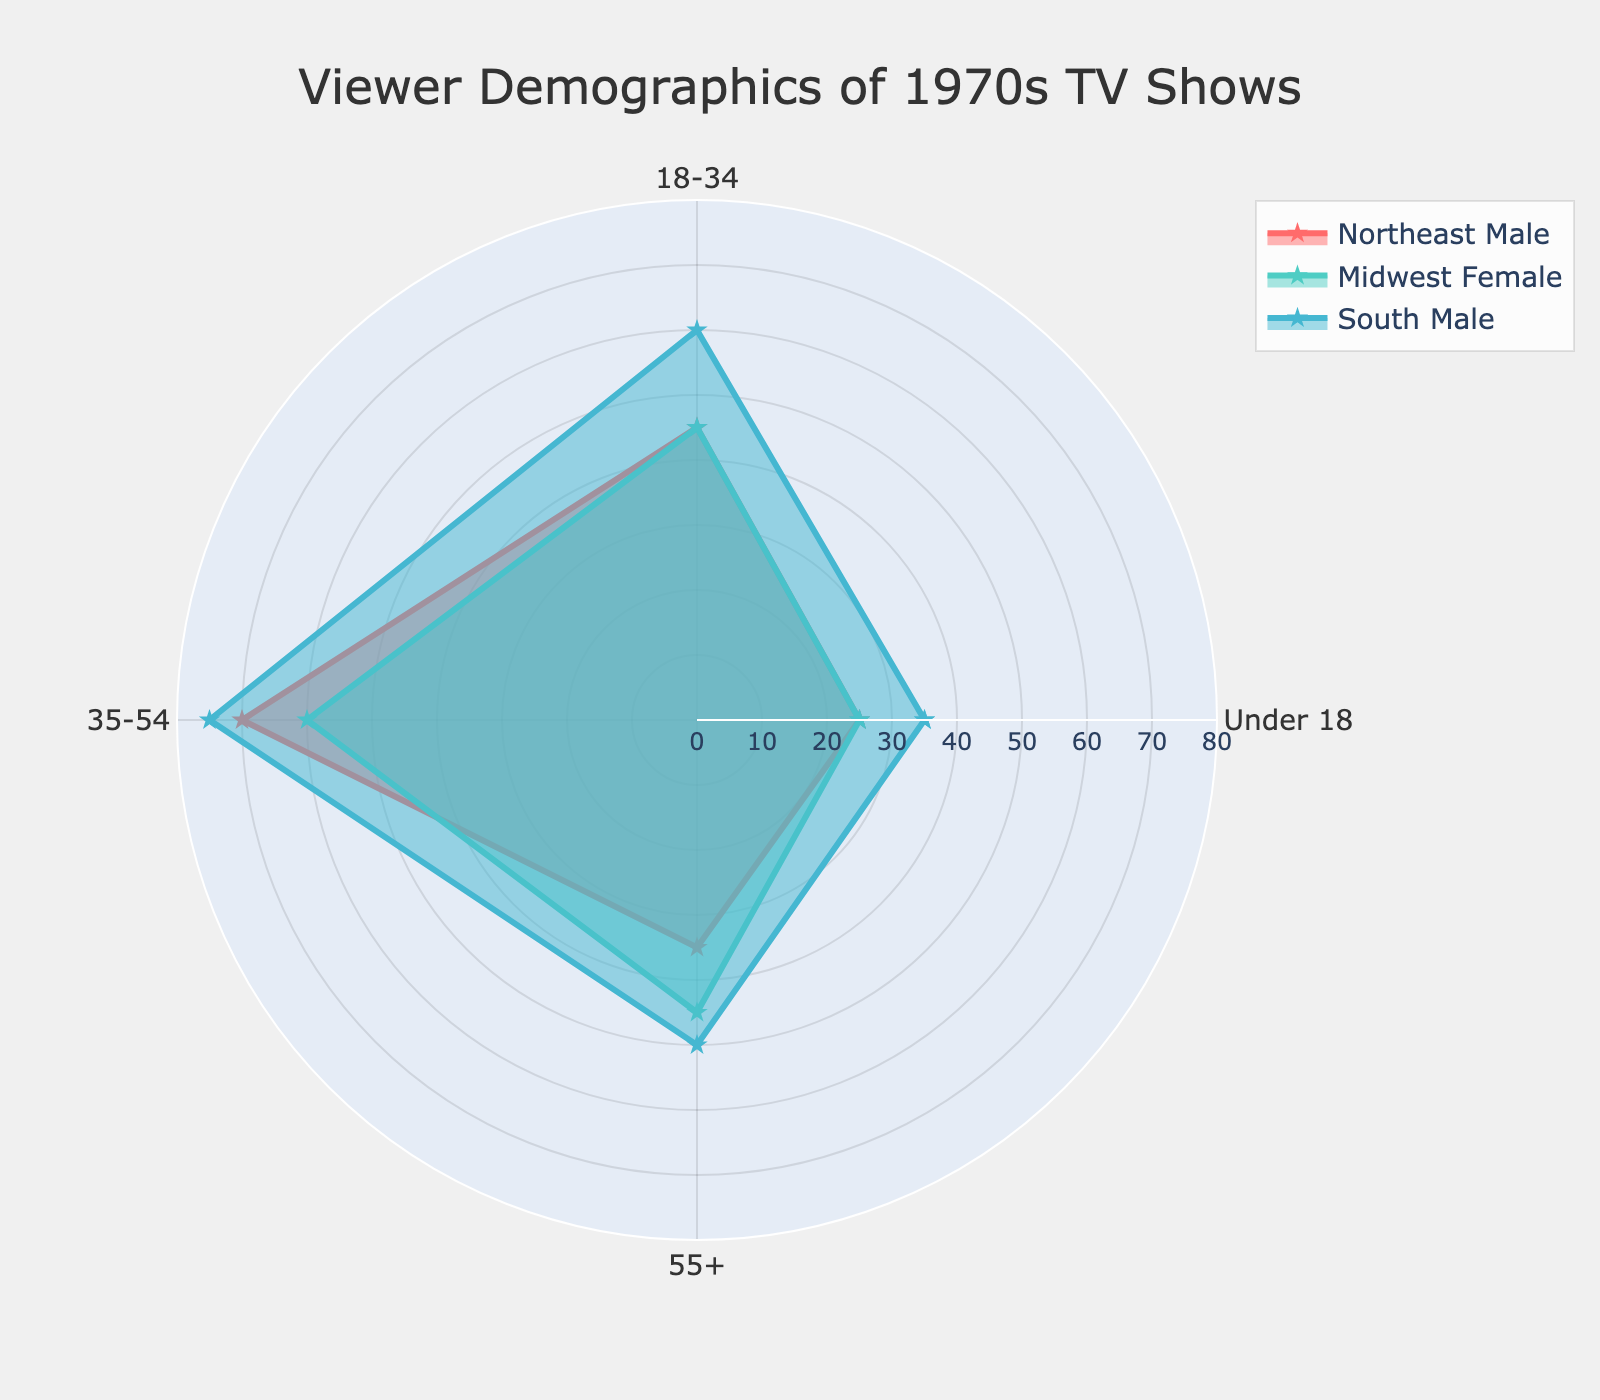What is the title of the radar chart? The title is provided at the top center of the radar chart, helping to identify the overall content.
Answer: Viewer Demographics of 1970s TV Shows How many age groups are depicted in the radar chart? By looking at the radial axis of the chart, we can see the number of categories labeled, representing the different age groups.
Answer: 4 Which selected group has the highest value for the 18-34 age group? By analyzing the lengths of the data points on the radar chart for the 18-34 age group, compare the values of Northeast Male, Midwest Female, and South Male.
Answer: South Male What is the difference in the number of viewers aged 35-54 between Northeast Male and Midwest Female? First, note the respective values from the chart for these groups in the 35-54 age range, then subtract the Midwest Female value from the Northeast Male value.
Answer: 10 Which age group has the largest spread in viewer numbers among the selected groups? Compare the range of values for each age group across the selected groups to find the one with the maximum difference between the highest and lowest values.
Answer: 18-34 What is the average number of viewers aged 55+ among the three selected groups? Sum the values for the 55+ age category for the selected groups and divide by the number of groups to find the average.
Answer: 40 In which age group is the South Male viewership exactly the same as the Northeast Male? Check each age group category for these two groups and find the one where their values are equal.
Answer: 35-54 How do the viewer numbers for Midwest Female in the Under 18 group compare to those for South Male in the same age group? Compare the specific values for each group in the Under 18 age category to determine which is greater.
Answer: South Male What pattern or trend can we observe for the viewer numbers as the age groups increase for the Northeast Male group? Observe the changes in the value for Northeast Male as the age category moves from Under 18 to 55+ to identify any increases or decreases.
Answer: Increase, decrease, then increase Which selected group has the smallest value for the Under 18 age group? Identify the values for the Under 18 age group for all selected groups and find the group with the smallest number.
Answer: Midwest Female 